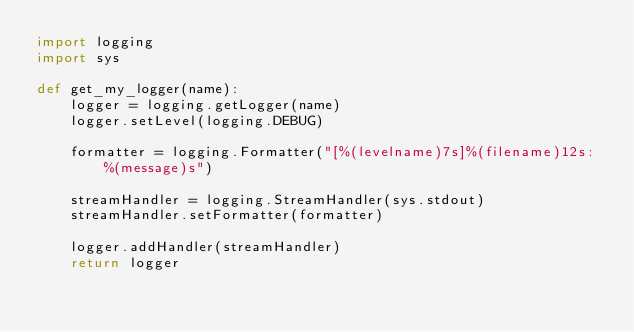Convert code to text. <code><loc_0><loc_0><loc_500><loc_500><_Python_>import logging
import sys

def get_my_logger(name):
    logger = logging.getLogger(name)
    logger.setLevel(logging.DEBUG)

    formatter = logging.Formatter("[%(levelname)7s]%(filename)12s: %(message)s")

    streamHandler = logging.StreamHandler(sys.stdout)
    streamHandler.setFormatter(formatter)

    logger.addHandler(streamHandler)
    return logger

</code> 